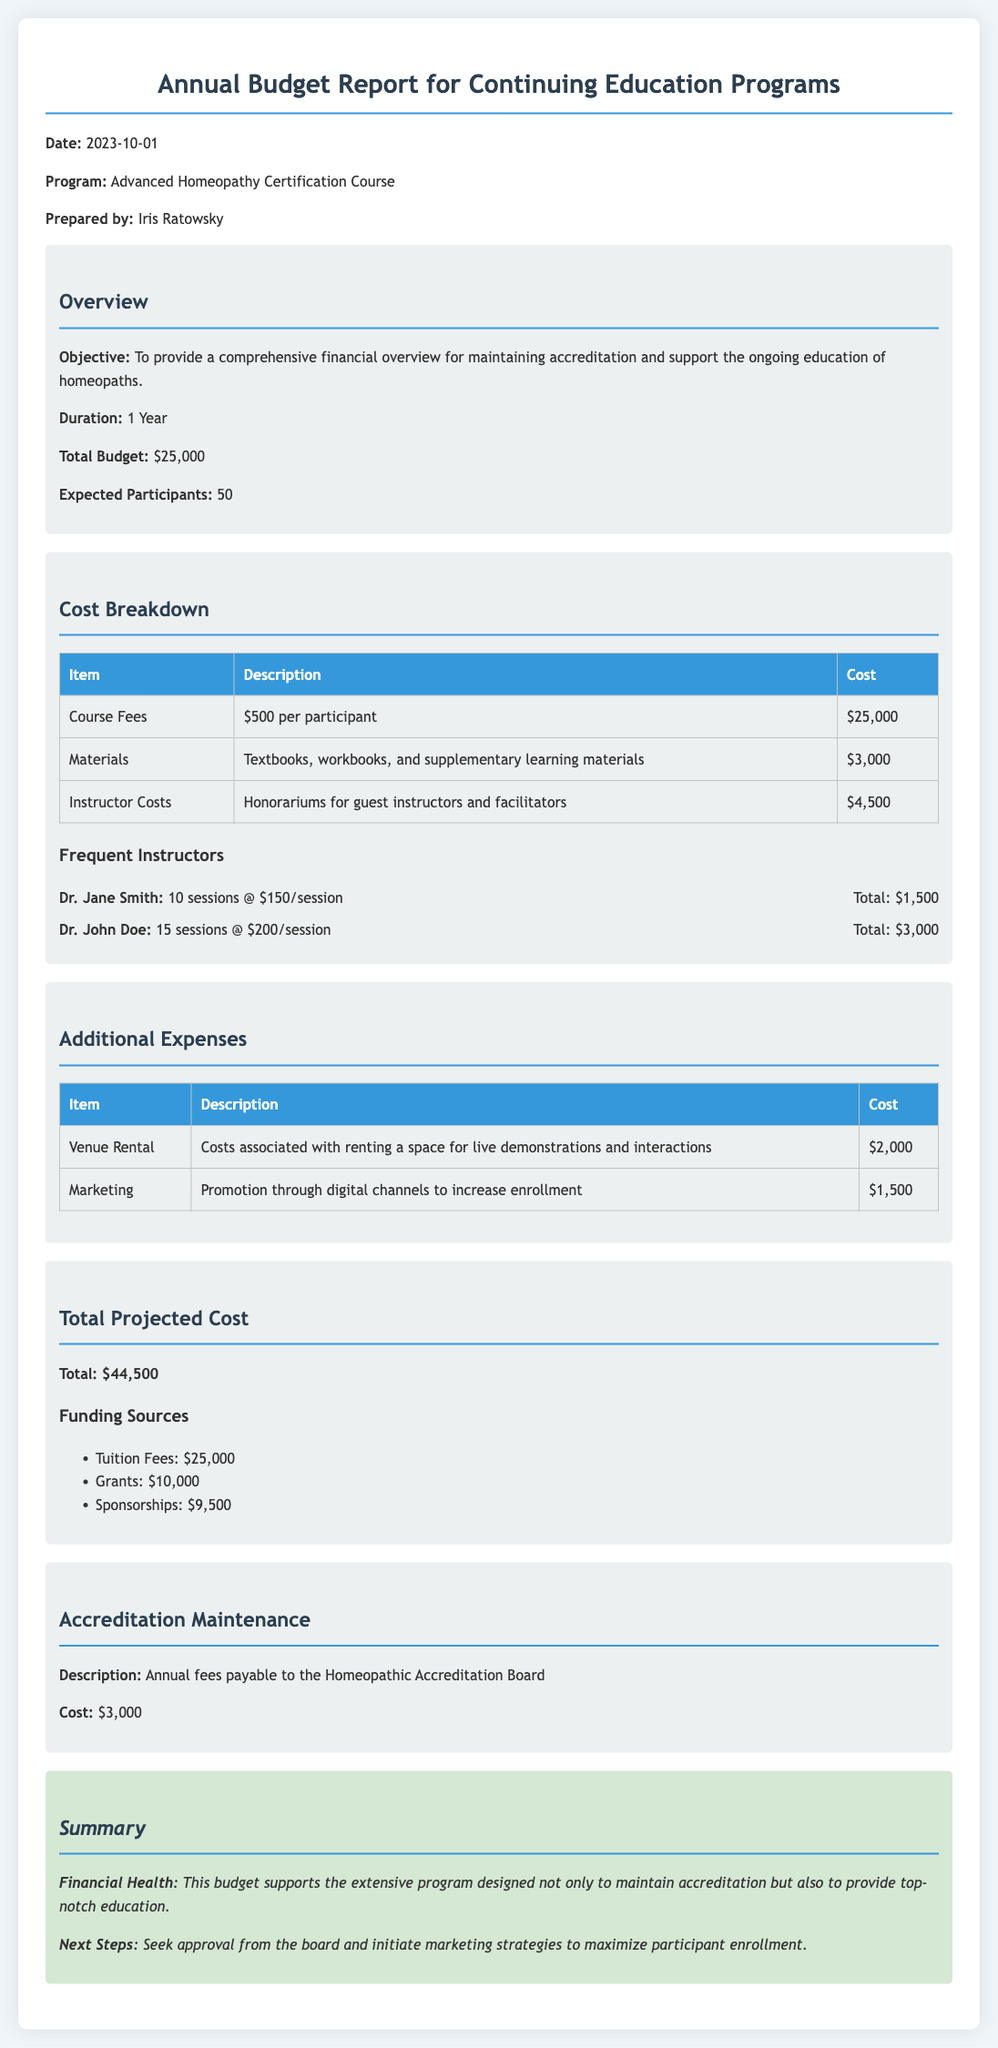What is the total budget? The total budget is specified in the document as $25,000.
Answer: $25,000 How many expected participants are there? The expected participants number is listed in the overview section.
Answer: 50 What is the cost for materials? The cost for materials is provided in the cost breakdown table.
Answer: $3,000 Who is the instructor with the highest total cost? The instructor costs are outlined, and the highest is Dr. John Doe with $3,000.
Answer: Dr. John Doe What is the cost of accreditation maintenance? The accreditation maintenance cost is detailed separately in the document.
Answer: $3,000 What is the total projected cost? The total projected cost is mentioned in the document as $44,500.
Answer: $44,500 What are the tuition fees? The tuition fees are indicated in the funding sources section of the document.
Answer: $25,000 What percentage of the total projected cost is covered by grants? Grants amounting to $10,000 constitute a part of the total projected cost. The percentage can be calculated as (10,000/44,500)*100, which reflects their contribution.
Answer: 22.5% What is the objective of the budget report? The objective is stated in the overview section and focuses on maintaining accreditation and supporting education.
Answer: To provide a comprehensive financial overview for maintaining accreditation and support the ongoing education of homeopaths 